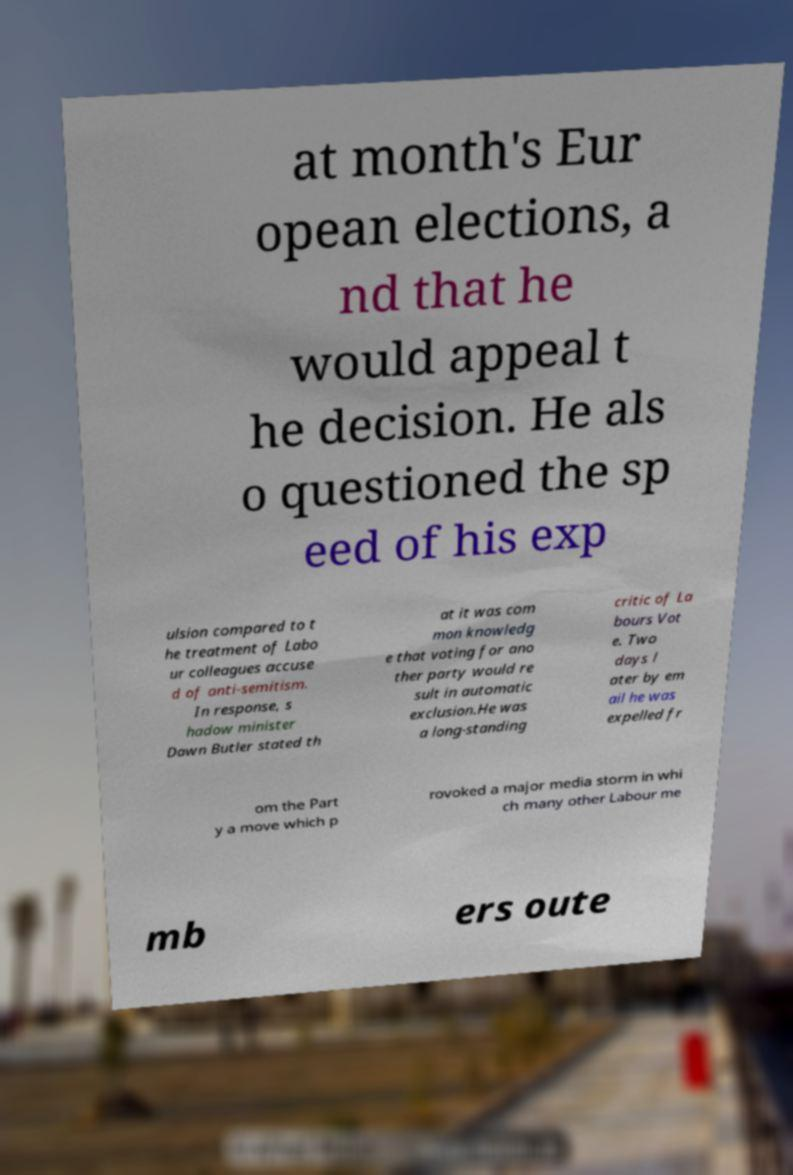Could you assist in decoding the text presented in this image and type it out clearly? at month's Eur opean elections, a nd that he would appeal t he decision. He als o questioned the sp eed of his exp ulsion compared to t he treatment of Labo ur colleagues accuse d of anti-semitism. In response, s hadow minister Dawn Butler stated th at it was com mon knowledg e that voting for ano ther party would re sult in automatic exclusion.He was a long-standing critic of La bours Vot e. Two days l ater by em ail he was expelled fr om the Part y a move which p rovoked a major media storm in whi ch many other Labour me mb ers oute 